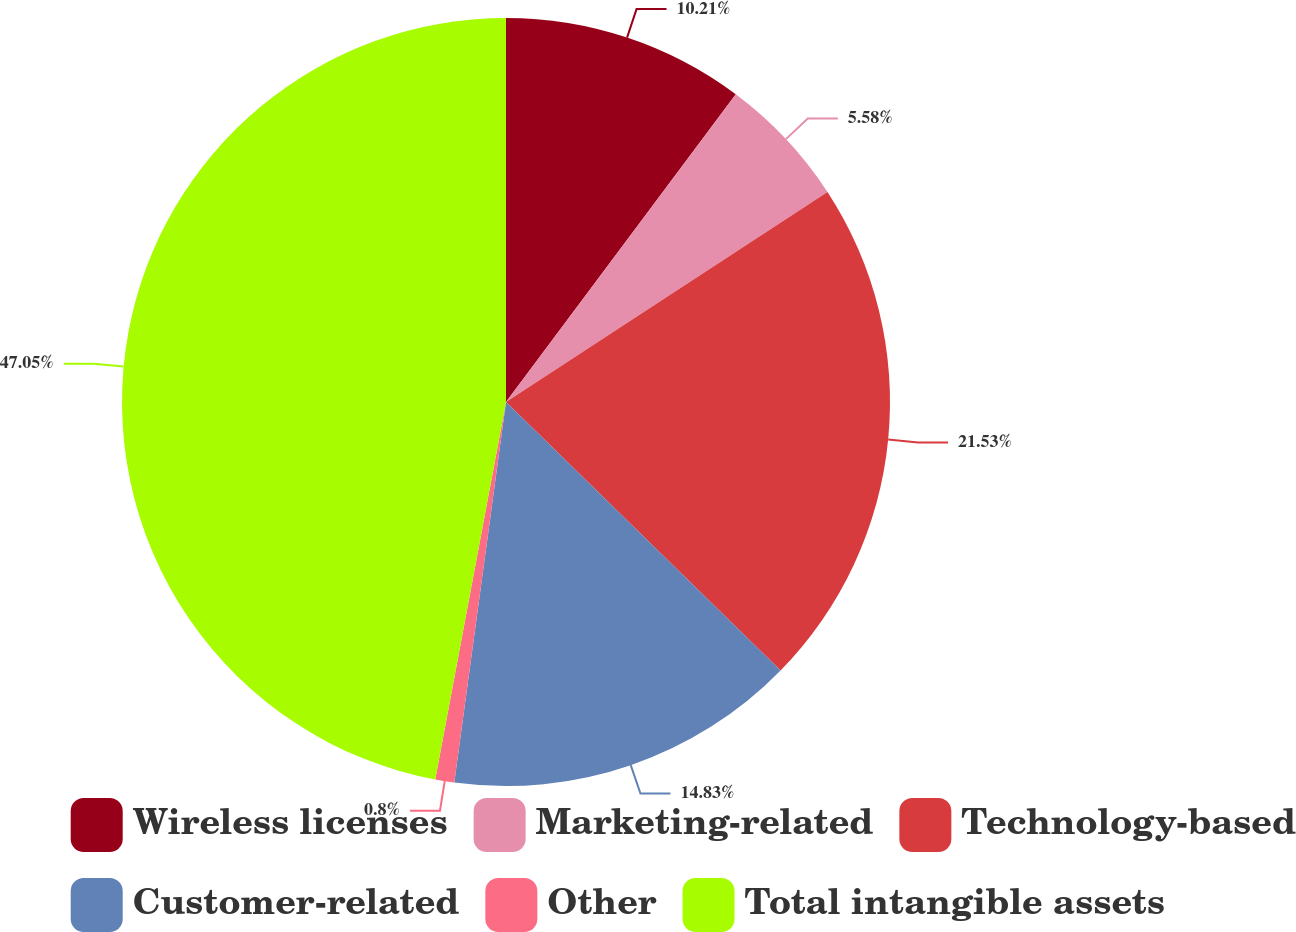<chart> <loc_0><loc_0><loc_500><loc_500><pie_chart><fcel>Wireless licenses<fcel>Marketing-related<fcel>Technology-based<fcel>Customer-related<fcel>Other<fcel>Total intangible assets<nl><fcel>10.21%<fcel>5.58%<fcel>21.53%<fcel>14.83%<fcel>0.8%<fcel>47.05%<nl></chart> 